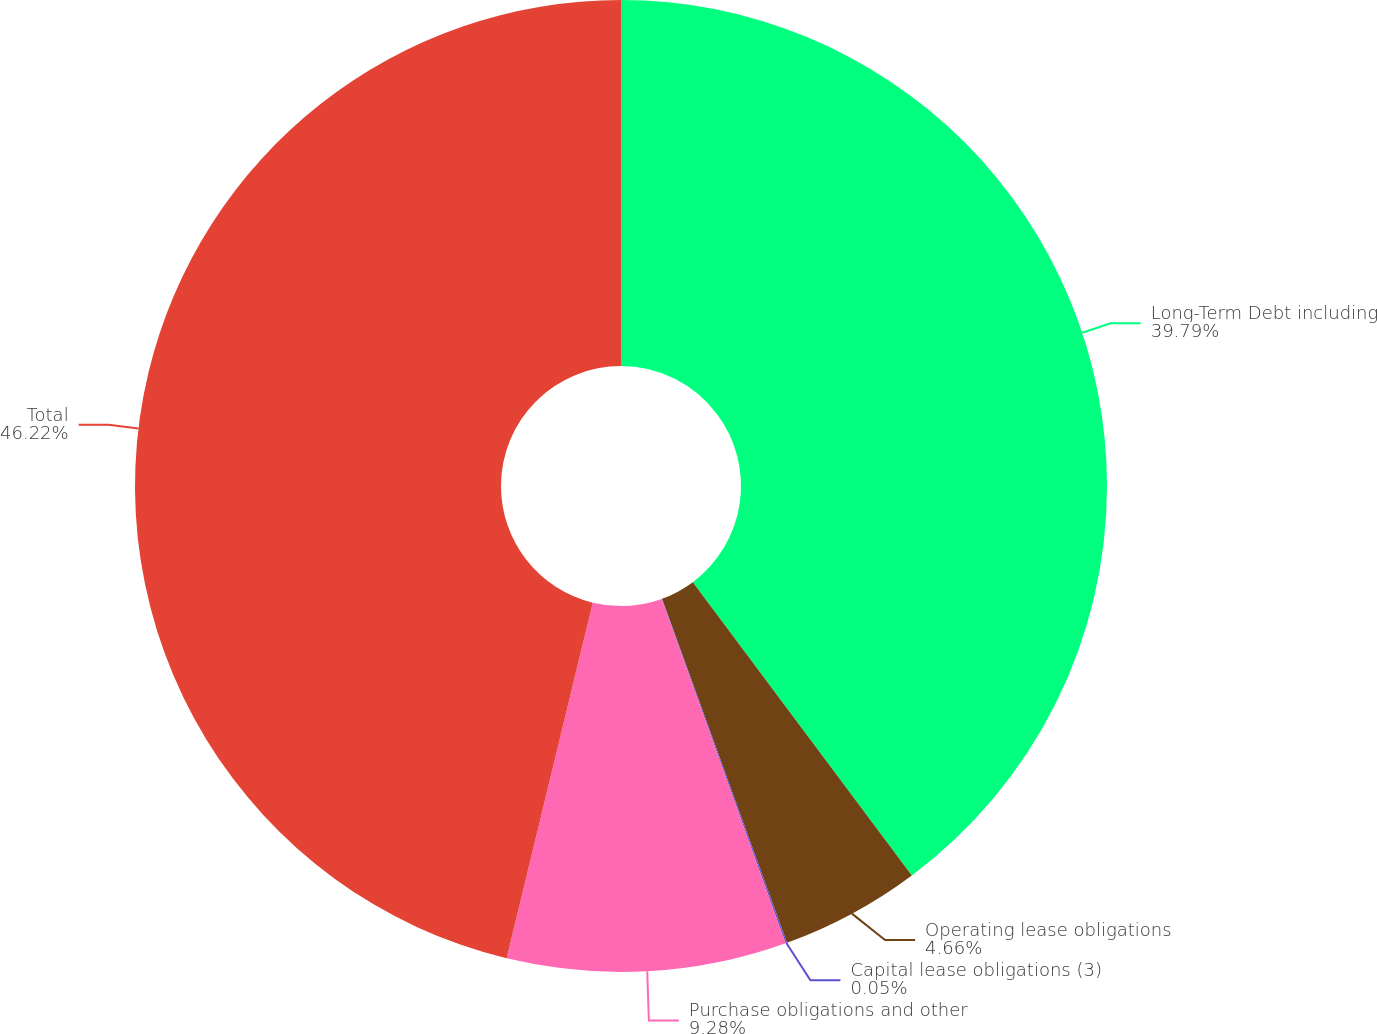Convert chart to OTSL. <chart><loc_0><loc_0><loc_500><loc_500><pie_chart><fcel>Long-Term Debt including<fcel>Operating lease obligations<fcel>Capital lease obligations (3)<fcel>Purchase obligations and other<fcel>Total<nl><fcel>39.79%<fcel>4.66%<fcel>0.05%<fcel>9.28%<fcel>46.22%<nl></chart> 